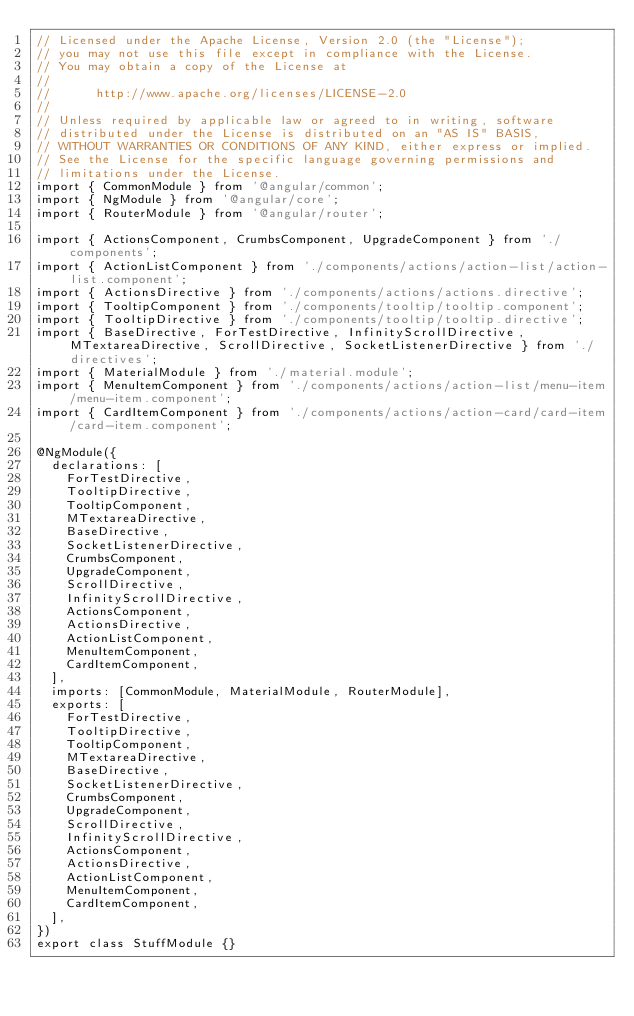Convert code to text. <code><loc_0><loc_0><loc_500><loc_500><_TypeScript_>// Licensed under the Apache License, Version 2.0 (the "License");
// you may not use this file except in compliance with the License.
// You may obtain a copy of the License at
//
//      http://www.apache.org/licenses/LICENSE-2.0
//
// Unless required by applicable law or agreed to in writing, software
// distributed under the License is distributed on an "AS IS" BASIS,
// WITHOUT WARRANTIES OR CONDITIONS OF ANY KIND, either express or implied.
// See the License for the specific language governing permissions and
// limitations under the License.
import { CommonModule } from '@angular/common';
import { NgModule } from '@angular/core';
import { RouterModule } from '@angular/router';

import { ActionsComponent, CrumbsComponent, UpgradeComponent } from './components';
import { ActionListComponent } from './components/actions/action-list/action-list.component';
import { ActionsDirective } from './components/actions/actions.directive';
import { TooltipComponent } from './components/tooltip/tooltip.component';
import { TooltipDirective } from './components/tooltip/tooltip.directive';
import { BaseDirective, ForTestDirective, InfinityScrollDirective, MTextareaDirective, ScrollDirective, SocketListenerDirective } from './directives';
import { MaterialModule } from './material.module';
import { MenuItemComponent } from './components/actions/action-list/menu-item/menu-item.component';
import { CardItemComponent } from './components/actions/action-card/card-item/card-item.component';

@NgModule({
  declarations: [
    ForTestDirective,
    TooltipDirective,
    TooltipComponent,
    MTextareaDirective,
    BaseDirective,
    SocketListenerDirective,
    CrumbsComponent,
    UpgradeComponent,
    ScrollDirective,
    InfinityScrollDirective,
    ActionsComponent,
    ActionsDirective,
    ActionListComponent,
    MenuItemComponent,
    CardItemComponent,
  ],
  imports: [CommonModule, MaterialModule, RouterModule],
  exports: [
    ForTestDirective,
    TooltipDirective,
    TooltipComponent,
    MTextareaDirective,
    BaseDirective,
    SocketListenerDirective,
    CrumbsComponent,
    UpgradeComponent,
    ScrollDirective,
    InfinityScrollDirective,
    ActionsComponent,
    ActionsDirective,
    ActionListComponent,
    MenuItemComponent,
    CardItemComponent,
  ],
})
export class StuffModule {}
</code> 